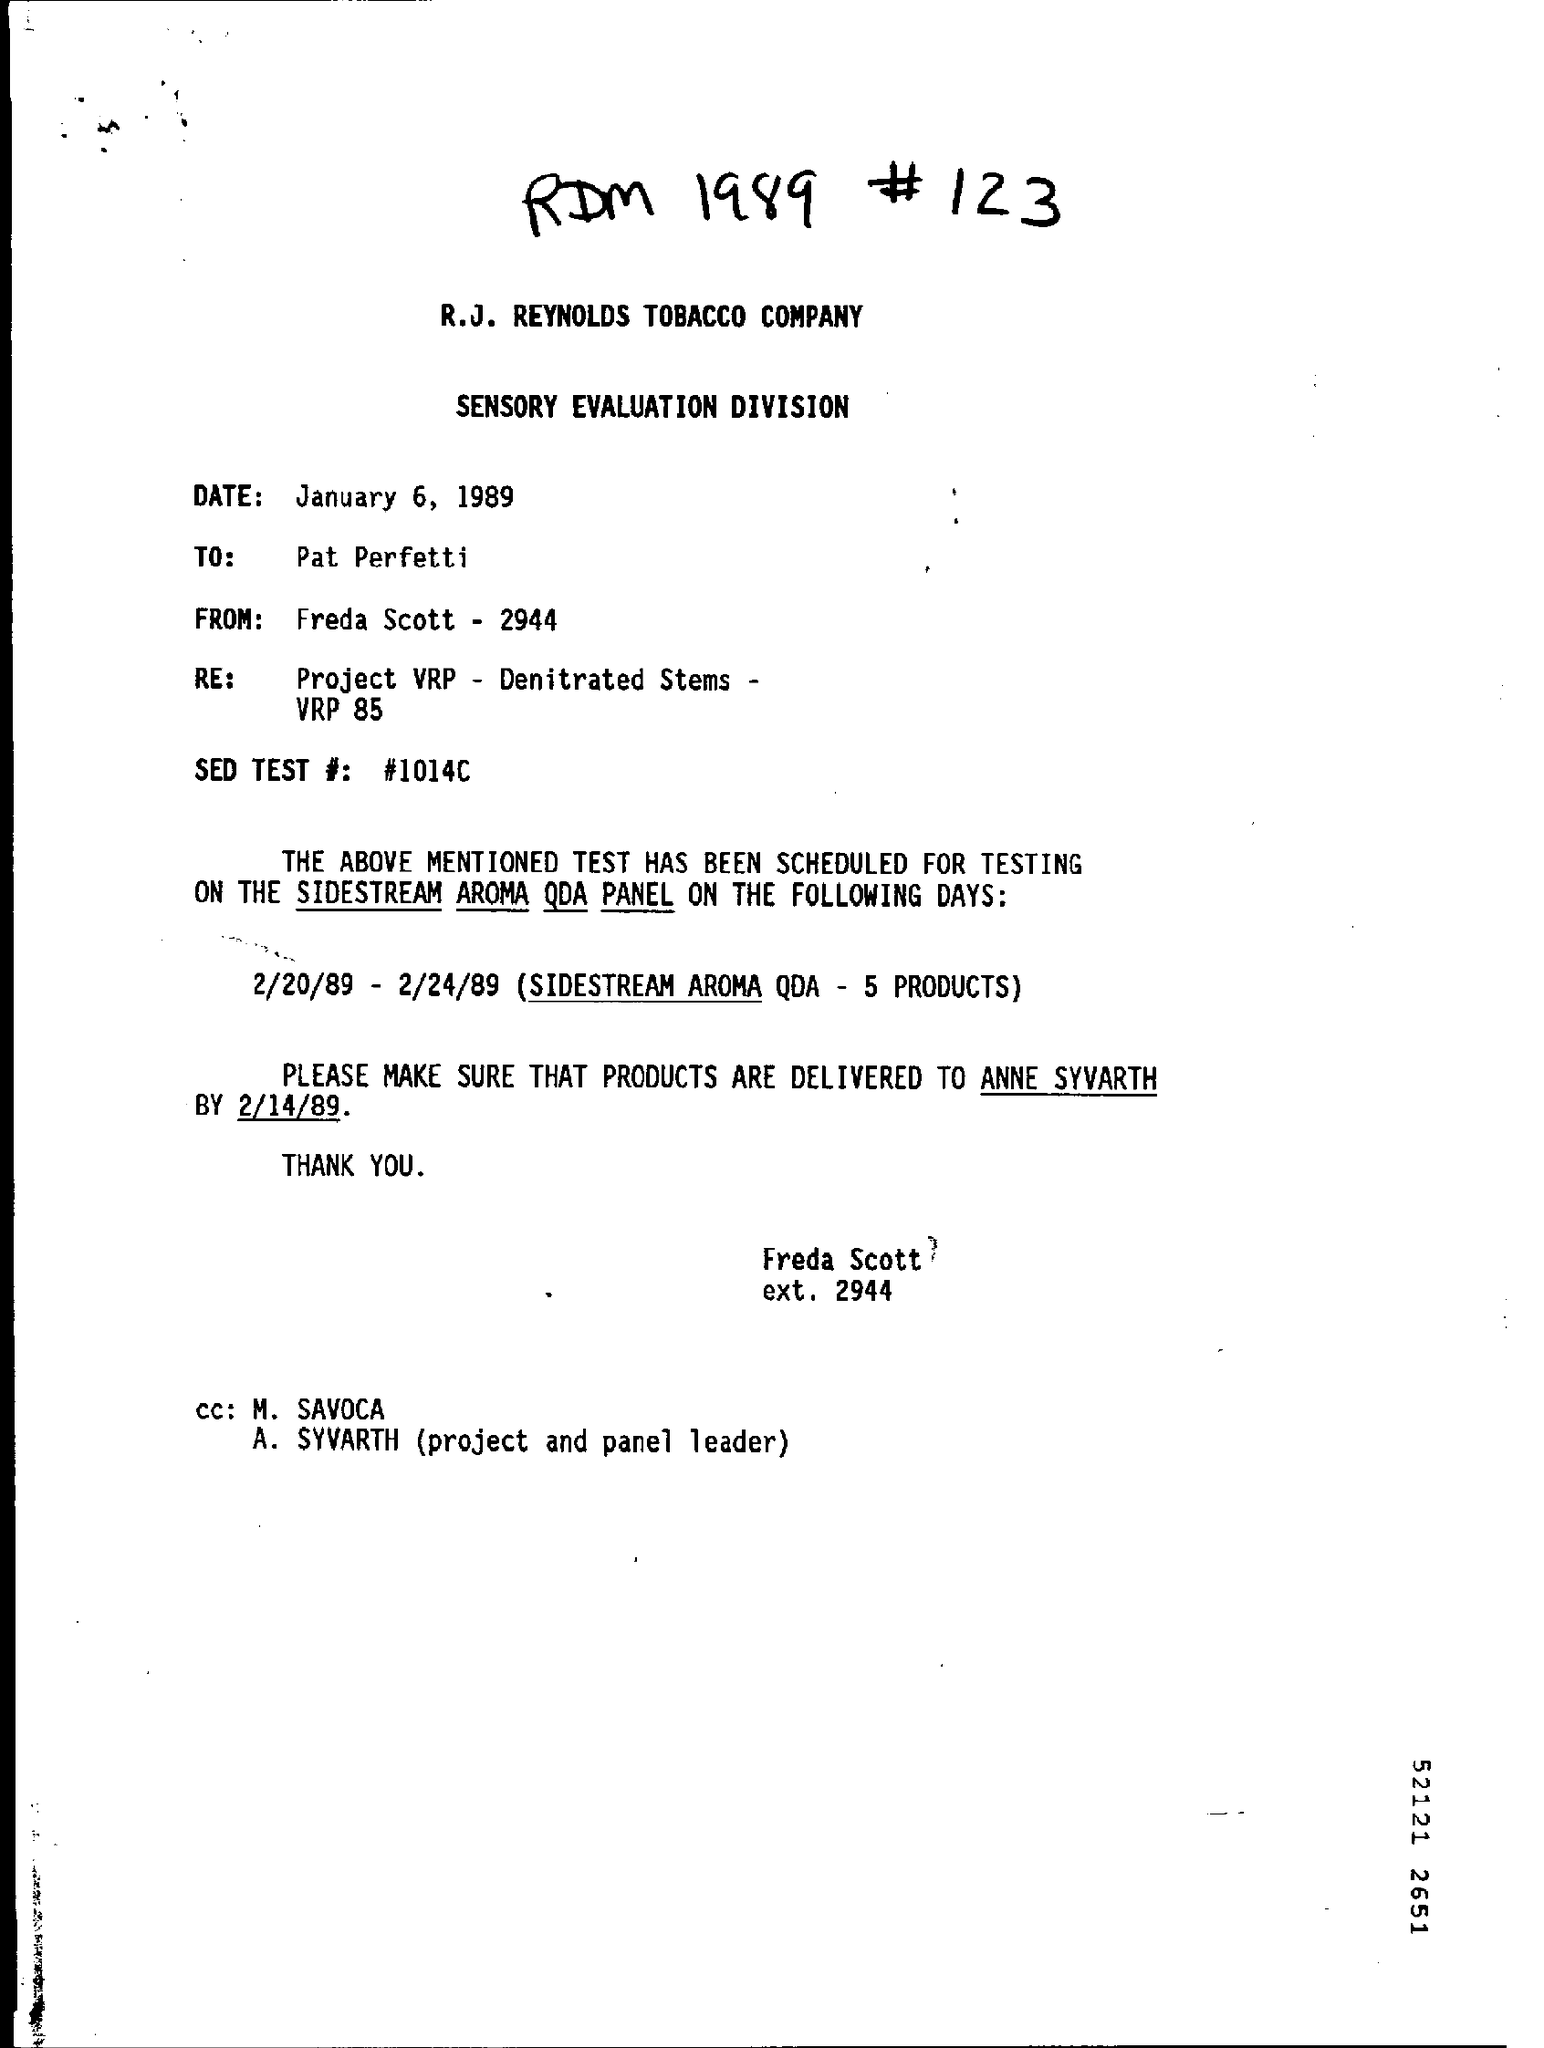Give some essential details in this illustration. The date mentioned is January 6, 1989. The "SED TEST #" is a number denoted as "#1014C..". The reference "RE : Project VRP - Denitrated Stems- VRP 85" likely refers to a report or document related to a project involving denitrified stems and virtual reality planning. However, without further context or information, it is difficult to provide a more specific declaration. 